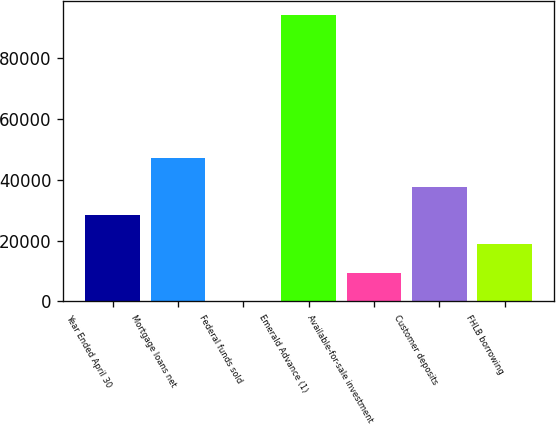Convert chart. <chart><loc_0><loc_0><loc_500><loc_500><bar_chart><fcel>Year Ended April 30<fcel>Mortgage loans net<fcel>Federal funds sold<fcel>Emerald Advance (1)<fcel>Available-for-sale investment<fcel>Customer deposits<fcel>FHLB borrowing<nl><fcel>28292.1<fcel>47151.5<fcel>3<fcel>94300<fcel>9432.7<fcel>37721.8<fcel>18862.4<nl></chart> 